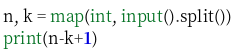<code> <loc_0><loc_0><loc_500><loc_500><_Python_>n, k = map(int, input().split())
print(n-k+1)</code> 